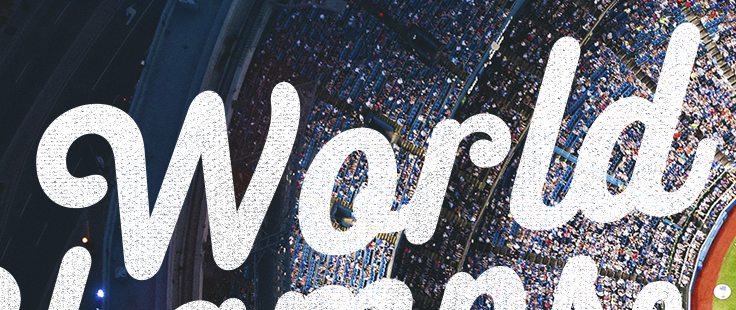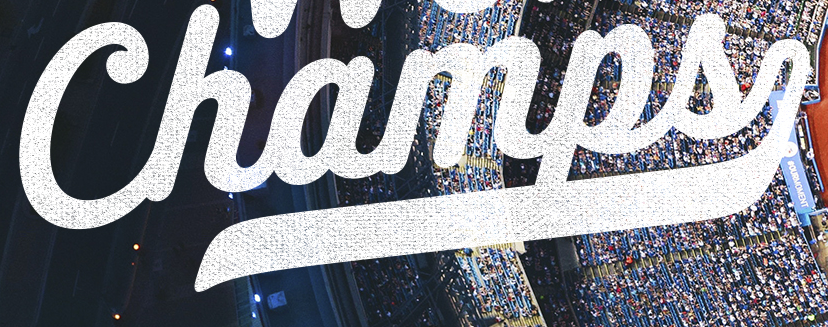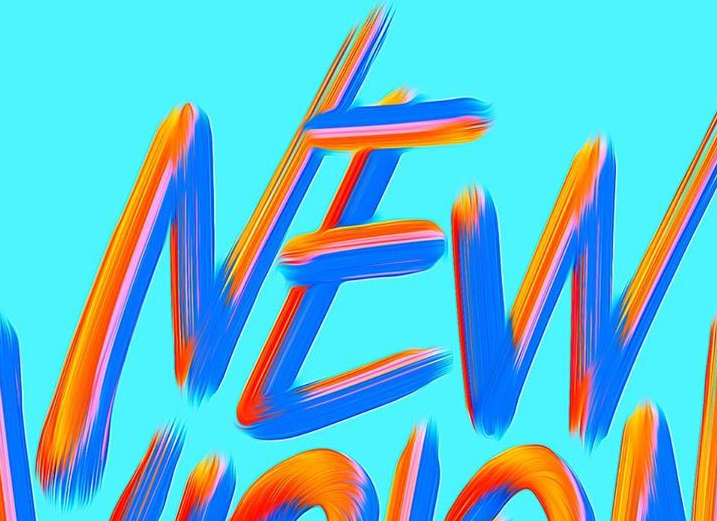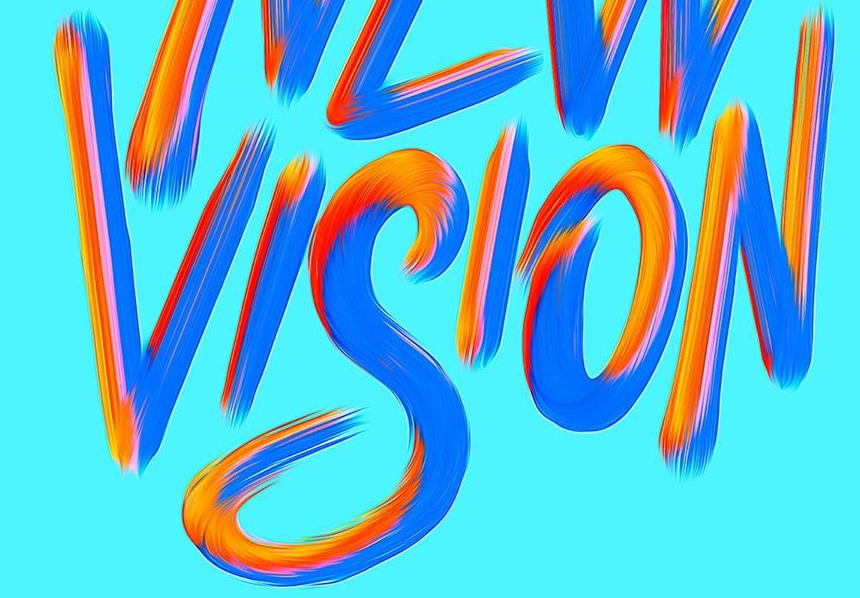Read the text content from these images in order, separated by a semicolon. World; Champs; NEW; VISION 